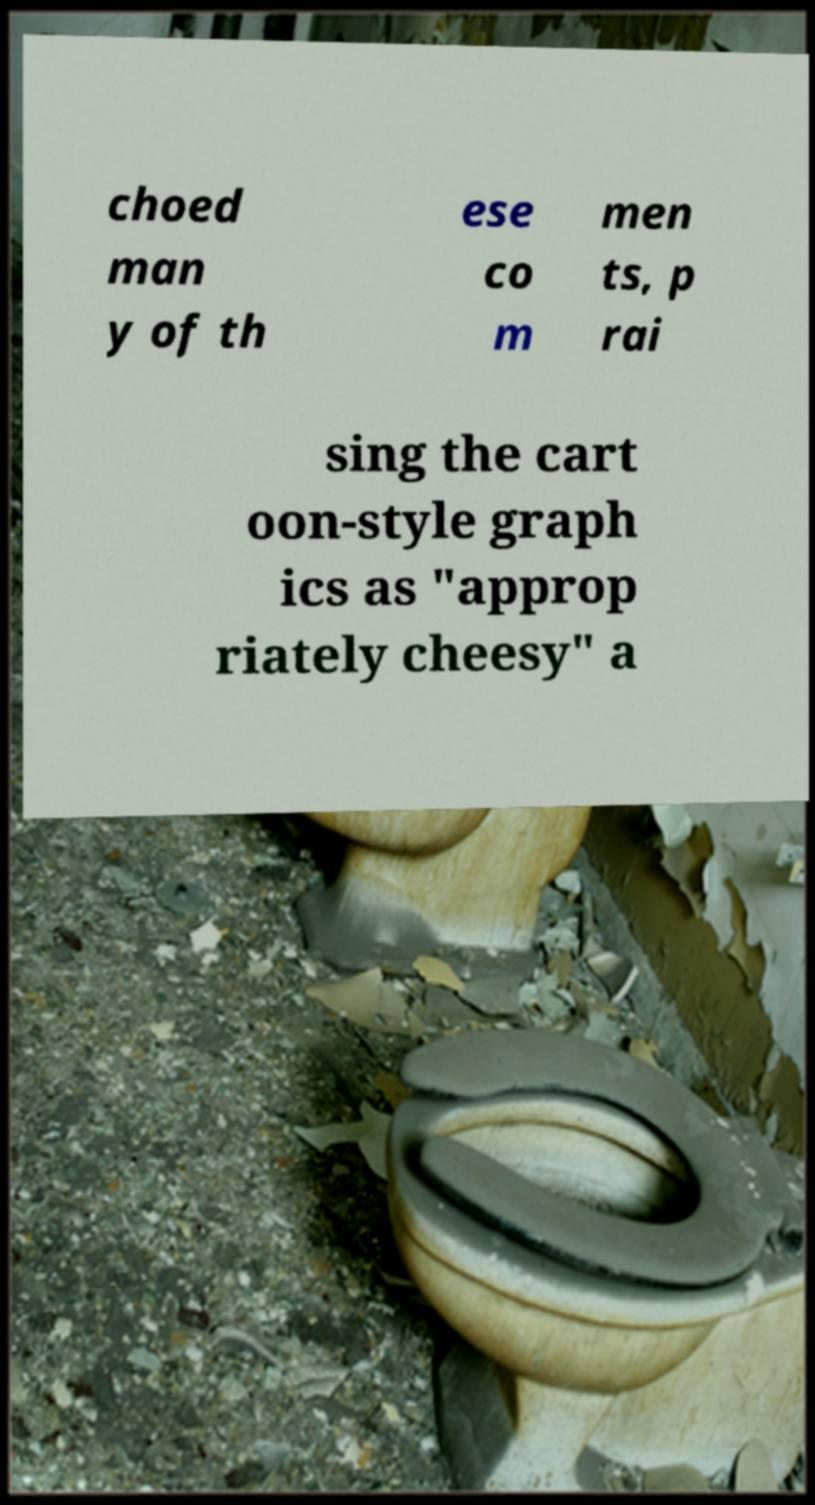Can you accurately transcribe the text from the provided image for me? choed man y of th ese co m men ts, p rai sing the cart oon-style graph ics as "approp riately cheesy" a 